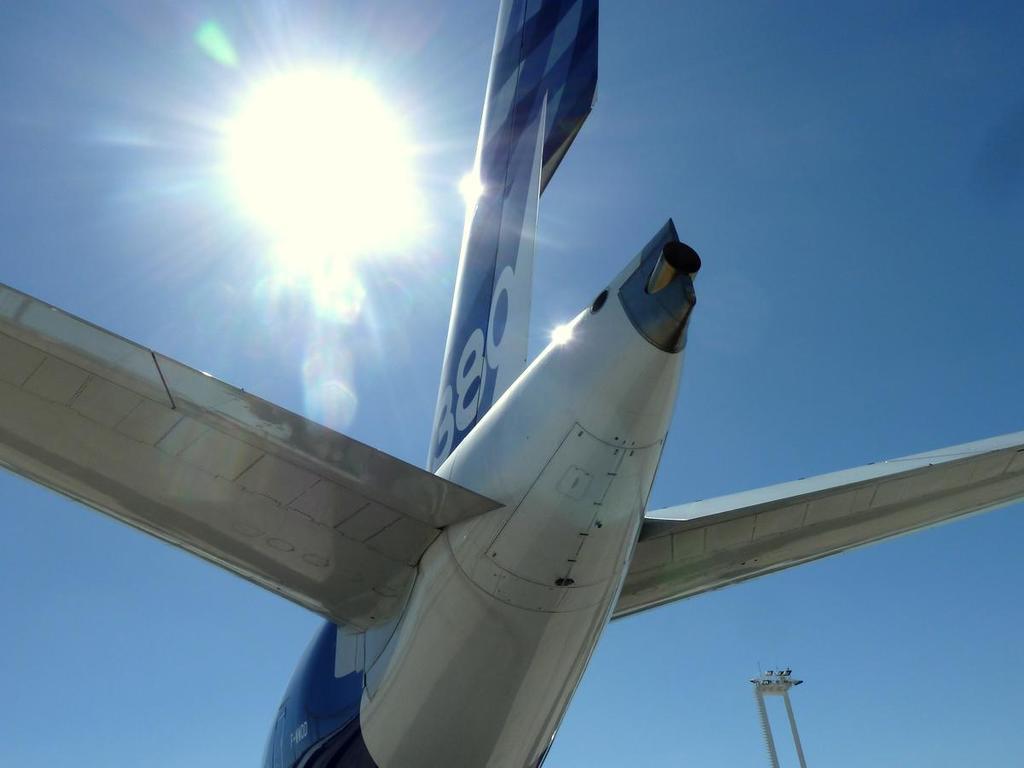Is this flight 889?
Ensure brevity in your answer.  Yes. The numbers on the tail are?
Ensure brevity in your answer.  880. 